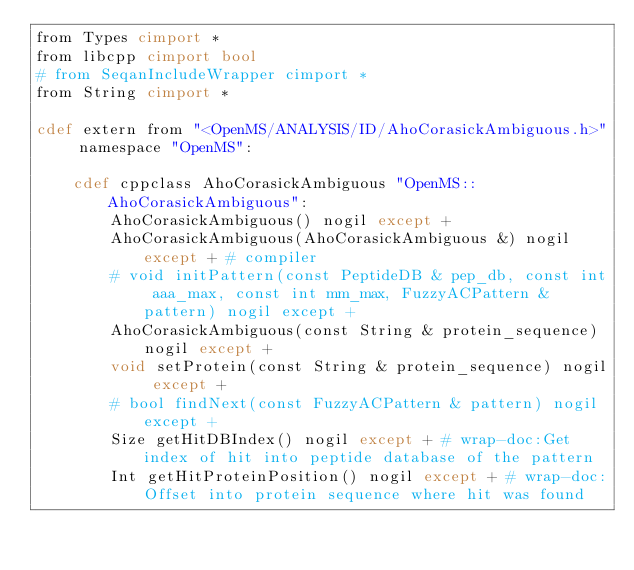Convert code to text. <code><loc_0><loc_0><loc_500><loc_500><_Cython_>from Types cimport *
from libcpp cimport bool
# from SeqanIncludeWrapper cimport *
from String cimport *

cdef extern from "<OpenMS/ANALYSIS/ID/AhoCorasickAmbiguous.h>" namespace "OpenMS":
    
    cdef cppclass AhoCorasickAmbiguous "OpenMS::AhoCorasickAmbiguous":
        AhoCorasickAmbiguous() nogil except +
        AhoCorasickAmbiguous(AhoCorasickAmbiguous &) nogil except + # compiler
        # void initPattern(const PeptideDB & pep_db, const int aaa_max, const int mm_max, FuzzyACPattern & pattern) nogil except +
        AhoCorasickAmbiguous(const String & protein_sequence) nogil except +
        void setProtein(const String & protein_sequence) nogil except +
        # bool findNext(const FuzzyACPattern & pattern) nogil except +
        Size getHitDBIndex() nogil except + # wrap-doc:Get index of hit into peptide database of the pattern
        Int getHitProteinPosition() nogil except + # wrap-doc:Offset into protein sequence where hit was found

</code> 